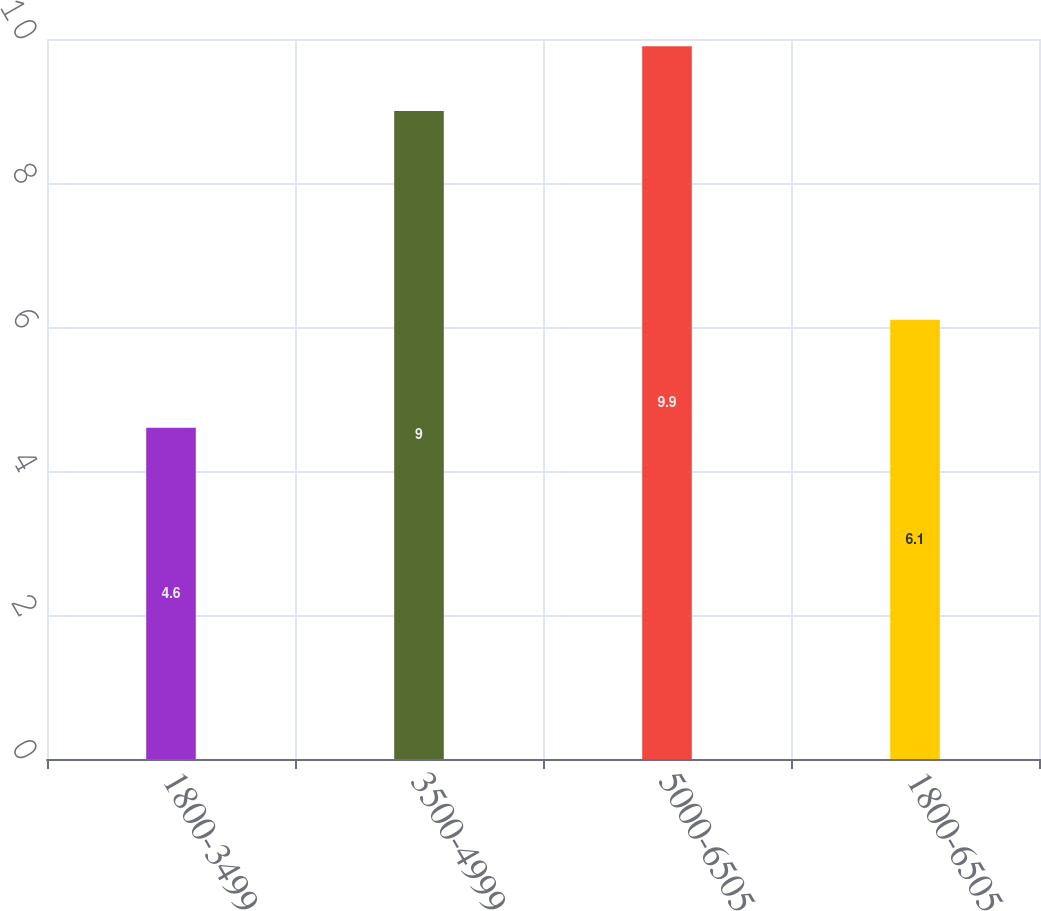<chart> <loc_0><loc_0><loc_500><loc_500><bar_chart><fcel>1800-3499<fcel>3500-4999<fcel>5000-6505<fcel>1800-6505<nl><fcel>4.6<fcel>9<fcel>9.9<fcel>6.1<nl></chart> 